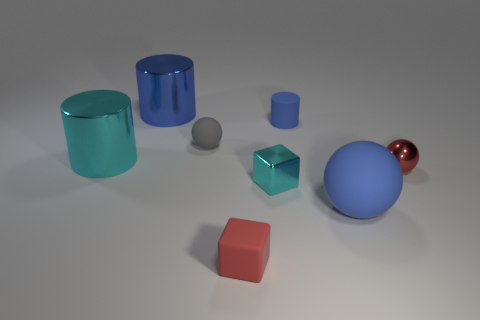Add 1 tiny gray rubber objects. How many objects exist? 9 Subtract all cylinders. How many objects are left? 5 Add 5 small red metal spheres. How many small red metal spheres exist? 6 Subtract 1 red spheres. How many objects are left? 7 Subtract all blue objects. Subtract all blue balls. How many objects are left? 4 Add 6 big cyan shiny cylinders. How many big cyan shiny cylinders are left? 7 